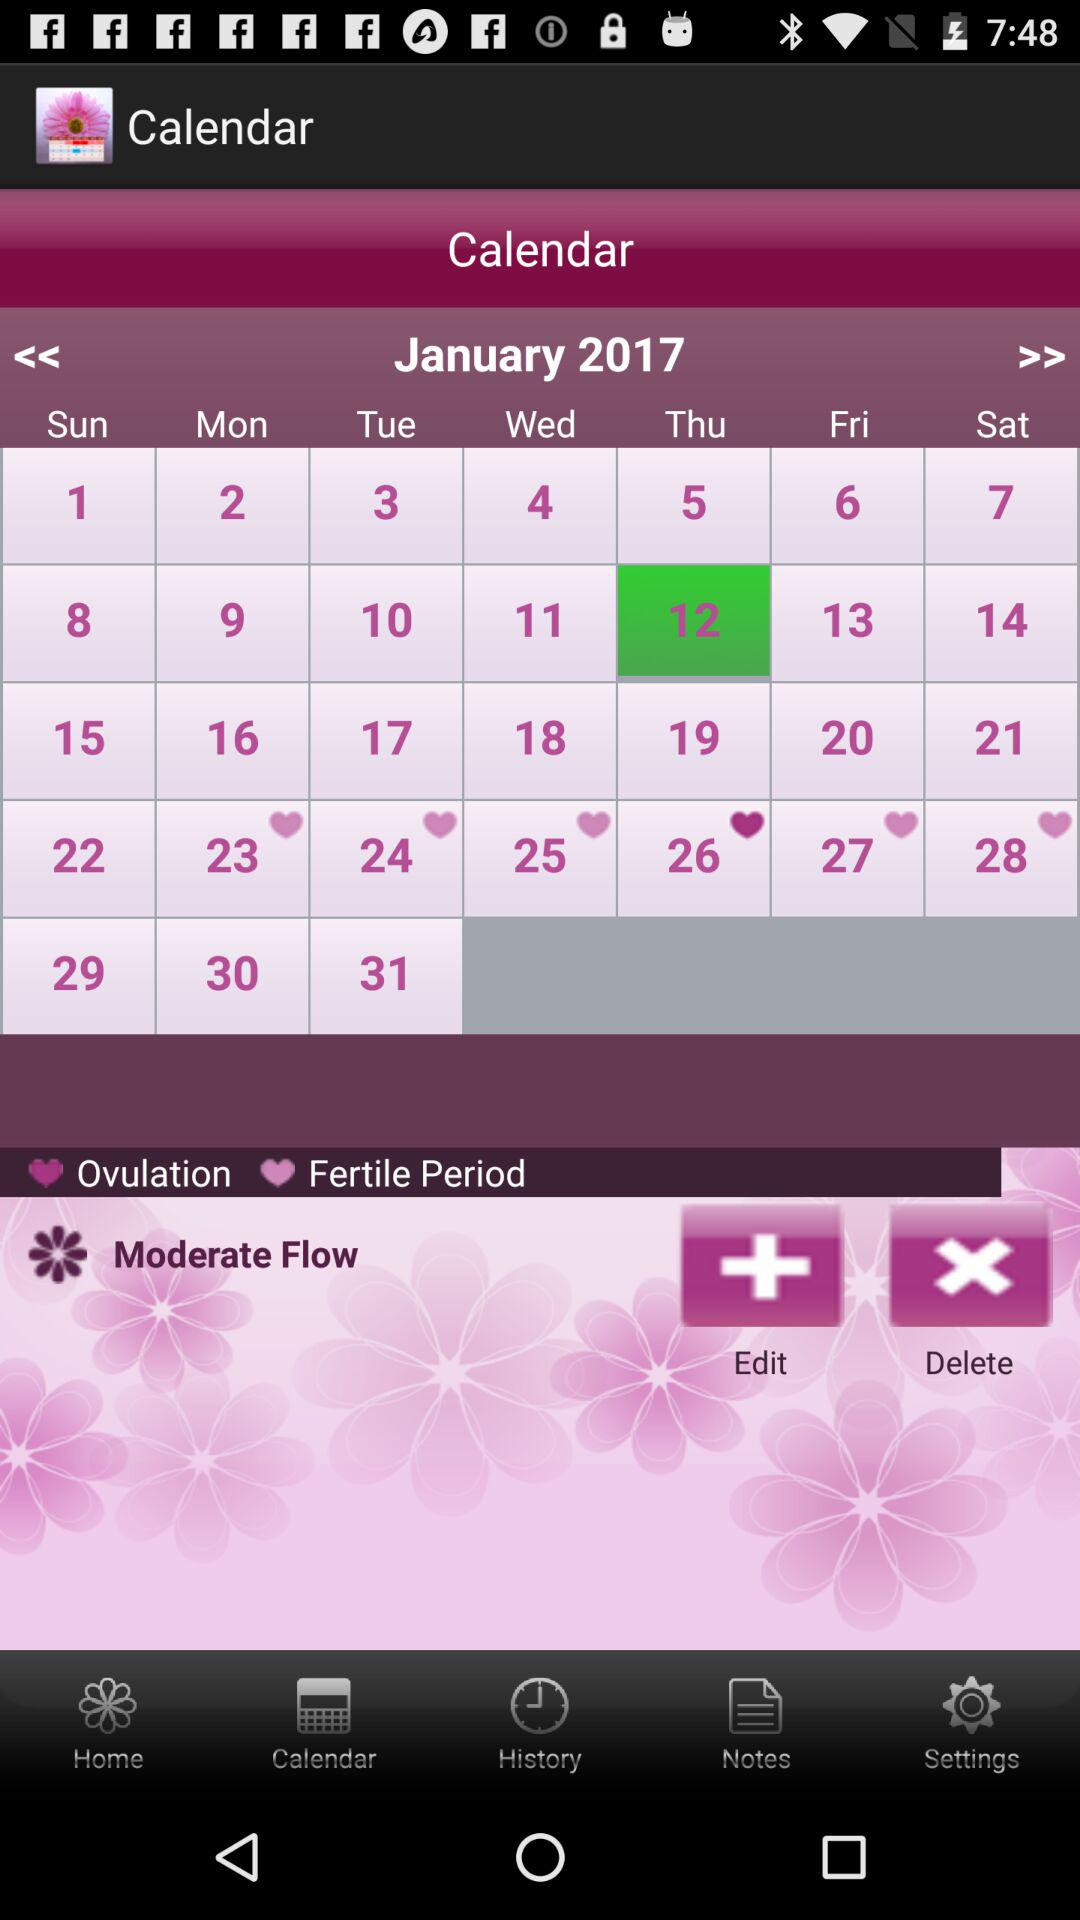What is the selected date? The selected date is Thursday, January 12, 2017. 